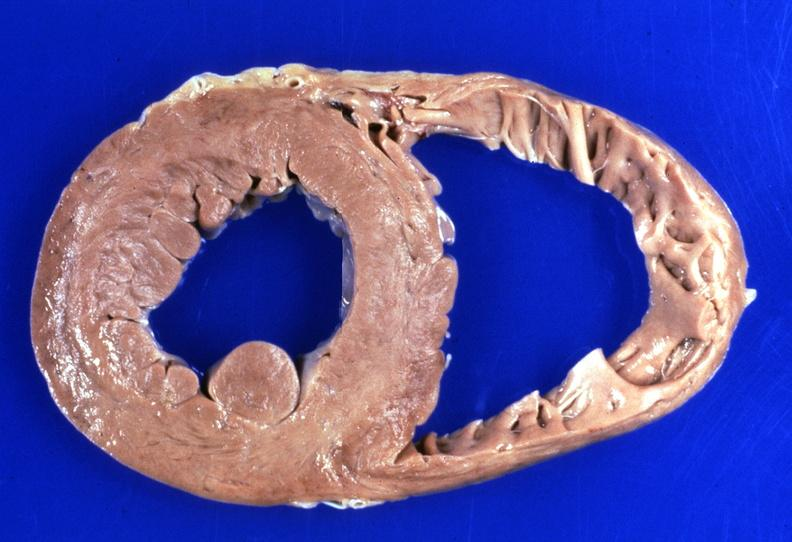what is present?
Answer the question using a single word or phrase. Cardiovascular 